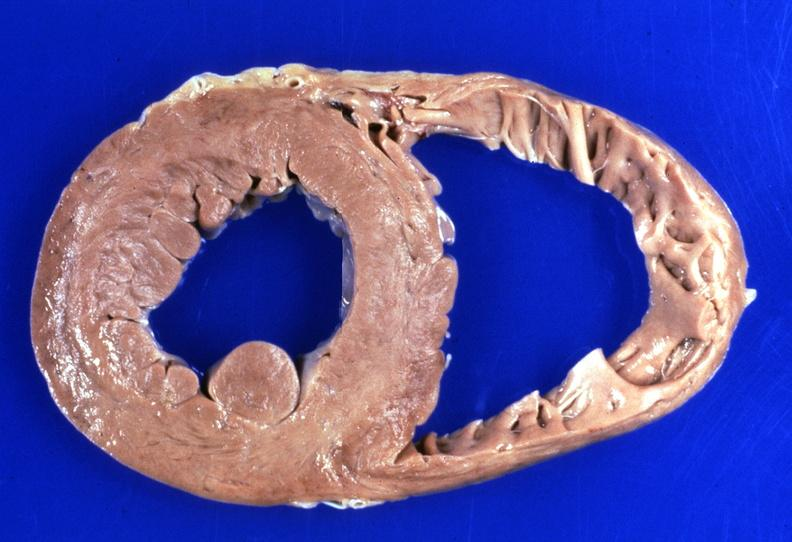what is present?
Answer the question using a single word or phrase. Cardiovascular 